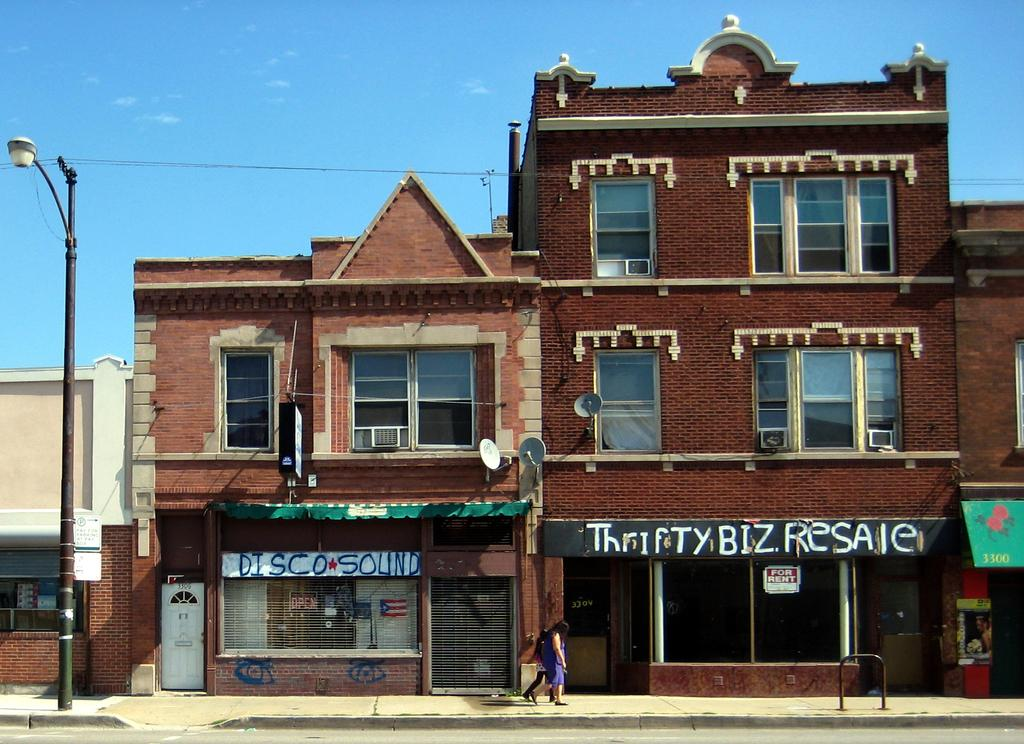What are the two persons in the image doing? The two persons in the image are walking. What type of structures can be seen in the image? There are buildings in the image. What else can be seen in the image besides the buildings? There are poles in the image. What is visible at the top of the image? There are clouds in the sky at the top of the image. What type of food is being carried in a pail by one of the persons in the image? There is no food or pail present in the image; the two persons are simply walking. 